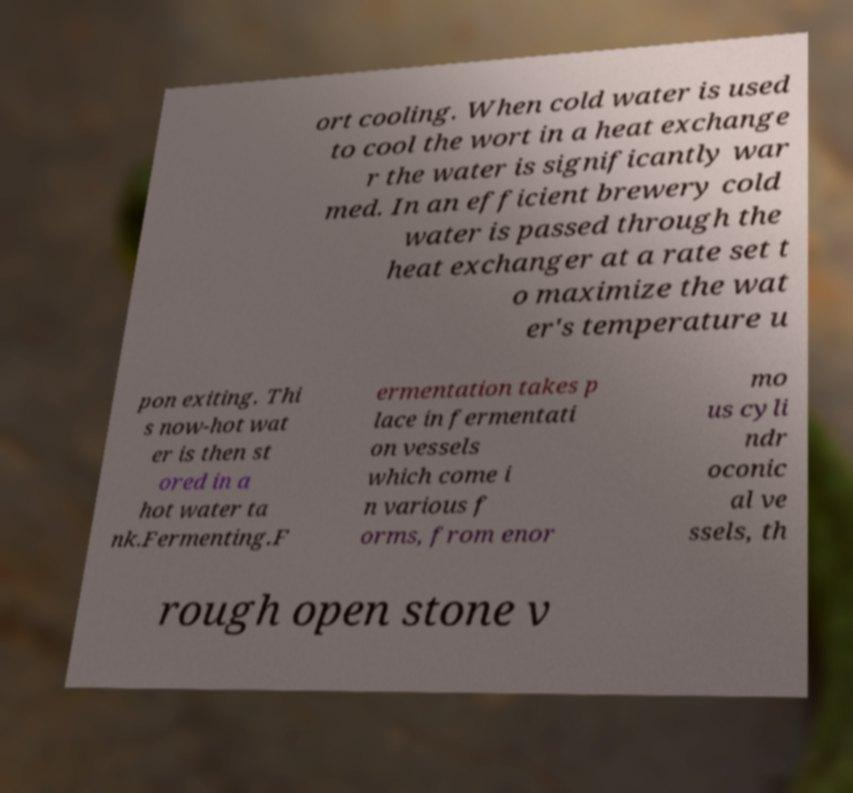I need the written content from this picture converted into text. Can you do that? ort cooling. When cold water is used to cool the wort in a heat exchange r the water is significantly war med. In an efficient brewery cold water is passed through the heat exchanger at a rate set t o maximize the wat er's temperature u pon exiting. Thi s now-hot wat er is then st ored in a hot water ta nk.Fermenting.F ermentation takes p lace in fermentati on vessels which come i n various f orms, from enor mo us cyli ndr oconic al ve ssels, th rough open stone v 